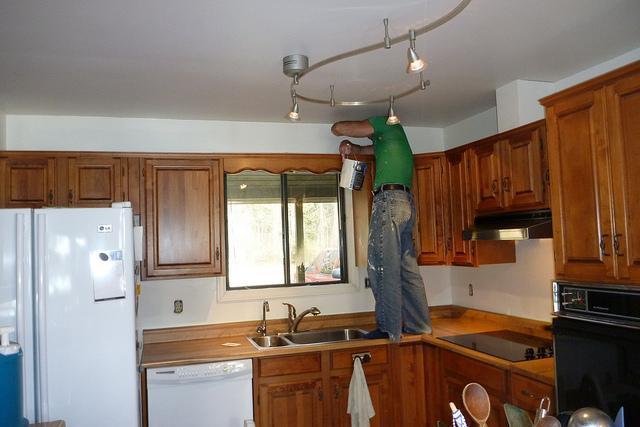Why is the man on the counter?
Choose the right answer and clarify with the format: 'Answer: answer
Rationale: rationale.'
Options: To paint, to surprise, to hide, to rest. Answer: to paint.
Rationale: The man is painting. 